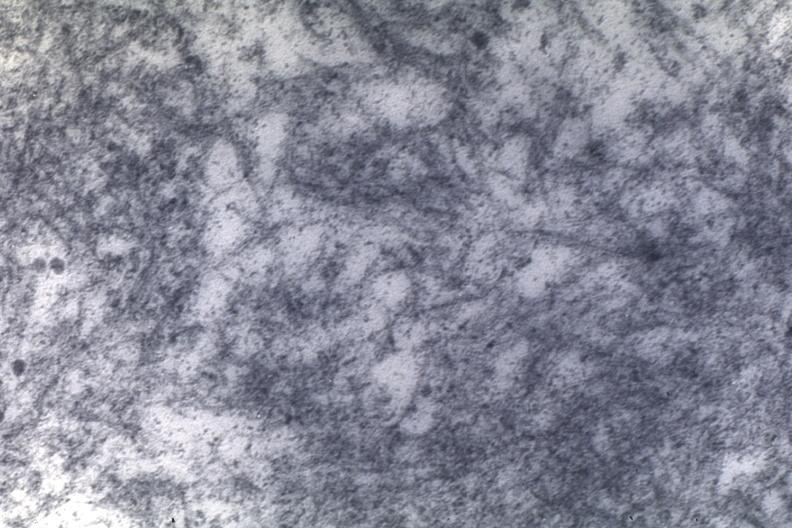s amyloidosis present?
Answer the question using a single word or phrase. Yes 